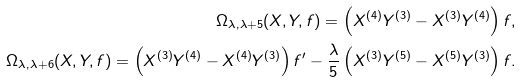<formula> <loc_0><loc_0><loc_500><loc_500>\Omega _ { \lambda , \lambda + 5 } ( X , Y , f ) = \left ( X ^ { ( 4 ) } Y ^ { ( 3 ) } - X ^ { ( 3 ) } Y ^ { ( 4 ) } \right ) f , \\ \Omega _ { \lambda , \lambda + 6 } ( X , Y , f ) = \left ( X ^ { ( 3 ) } Y ^ { ( 4 ) } - X ^ { ( 4 ) } Y ^ { ( 3 ) } \right ) f ^ { \prime } - \frac { \lambda } { 5 } \left ( X ^ { ( 3 ) } Y ^ { ( 5 ) } - X ^ { ( 5 ) } Y ^ { ( 3 ) } \right ) f .</formula> 